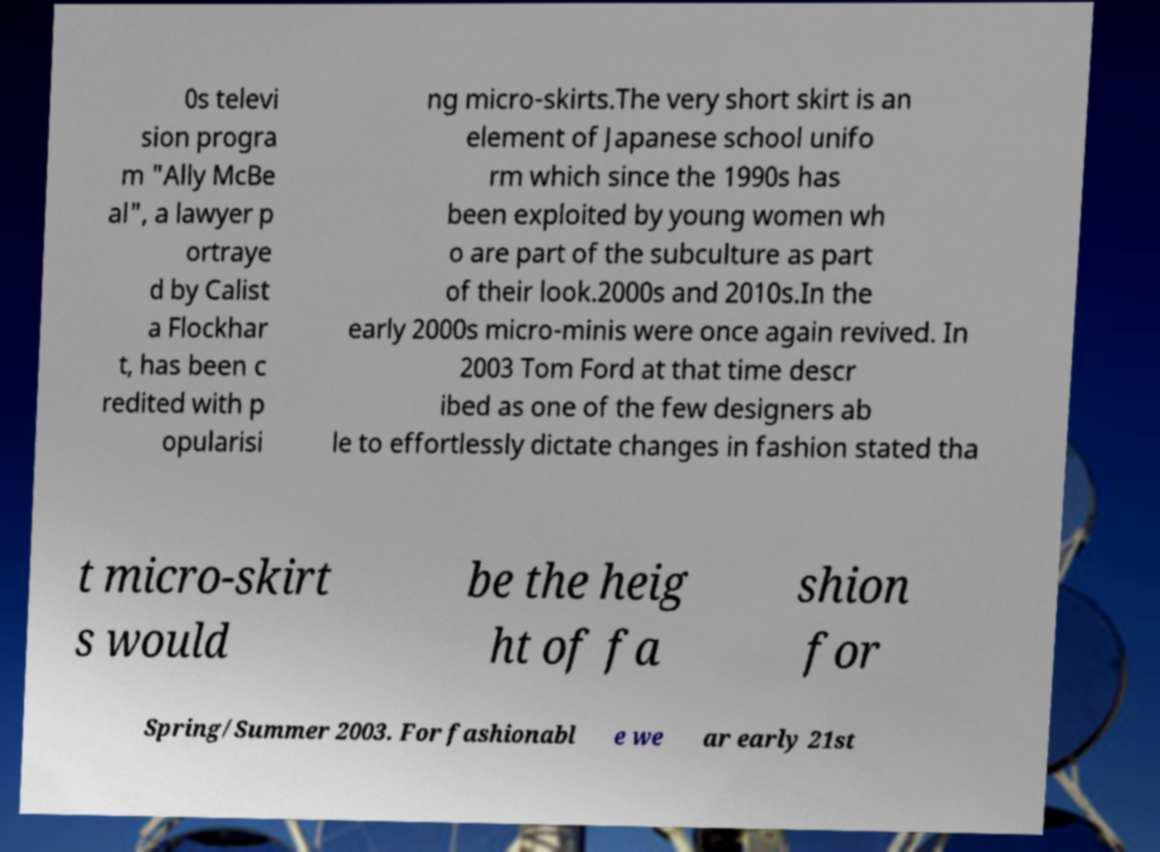I need the written content from this picture converted into text. Can you do that? 0s televi sion progra m "Ally McBe al", a lawyer p ortraye d by Calist a Flockhar t, has been c redited with p opularisi ng micro-skirts.The very short skirt is an element of Japanese school unifo rm which since the 1990s has been exploited by young women wh o are part of the subculture as part of their look.2000s and 2010s.In the early 2000s micro-minis were once again revived. In 2003 Tom Ford at that time descr ibed as one of the few designers ab le to effortlessly dictate changes in fashion stated tha t micro-skirt s would be the heig ht of fa shion for Spring/Summer 2003. For fashionabl e we ar early 21st 